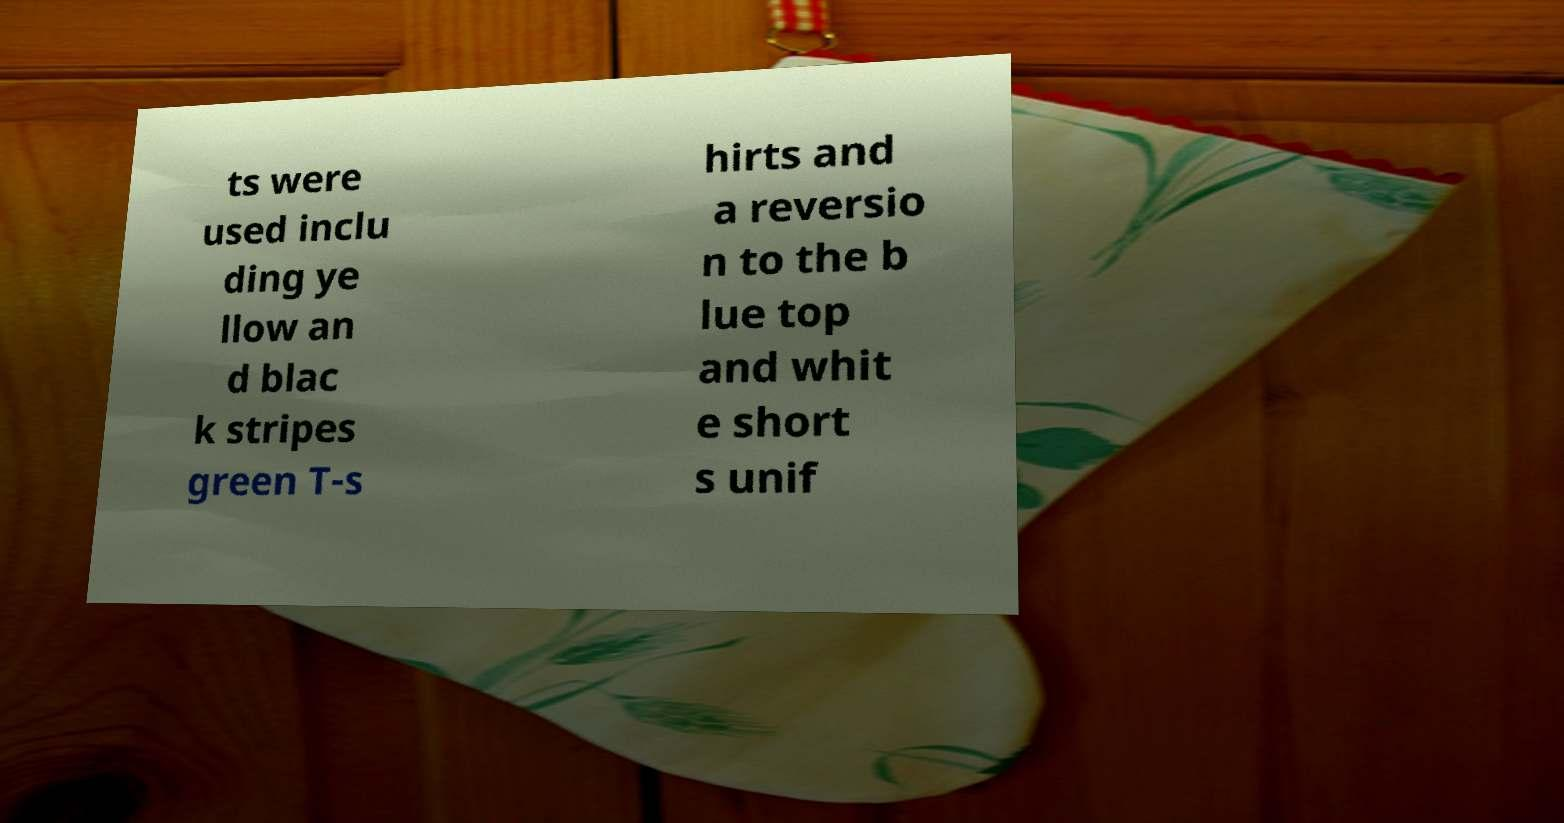I need the written content from this picture converted into text. Can you do that? ts were used inclu ding ye llow an d blac k stripes green T-s hirts and a reversio n to the b lue top and whit e short s unif 